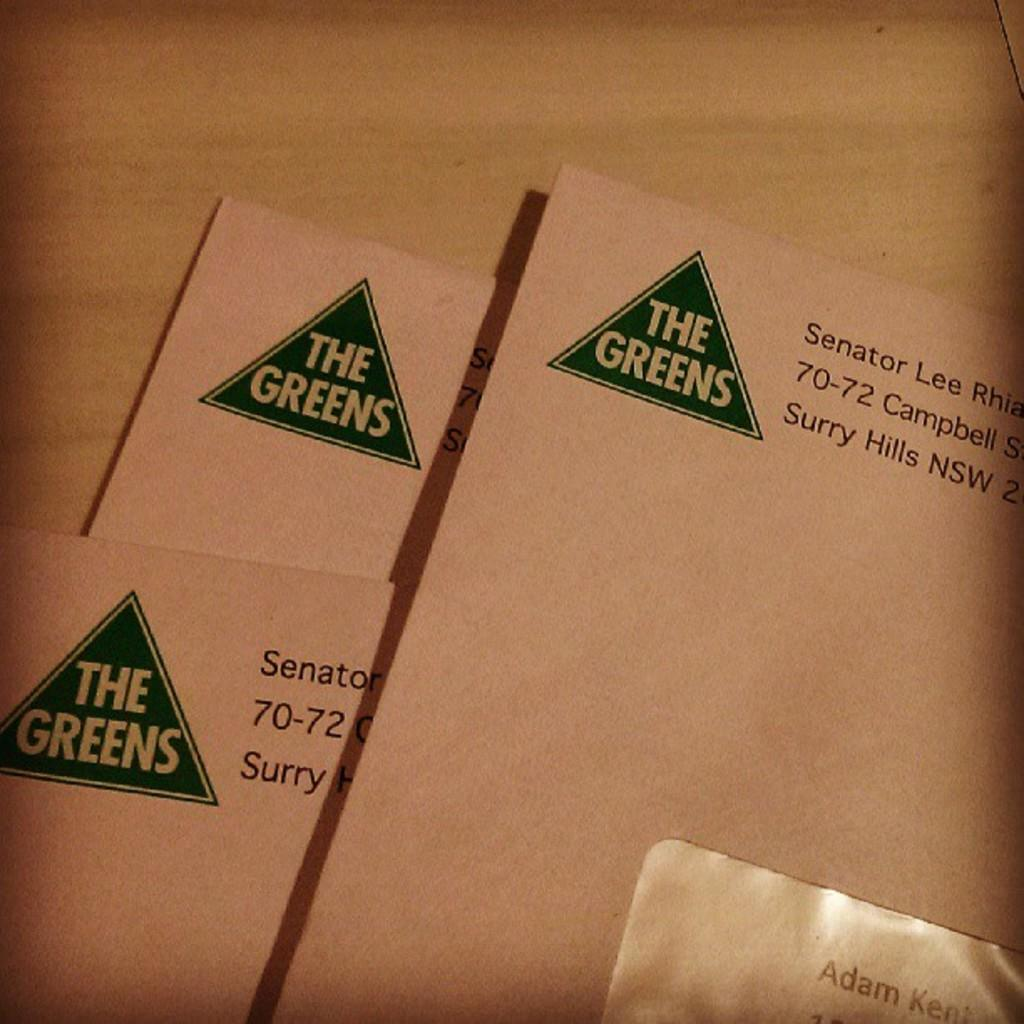<image>
Relay a brief, clear account of the picture shown. Three envelops that says "The Greens" placed on a wooden surface. 